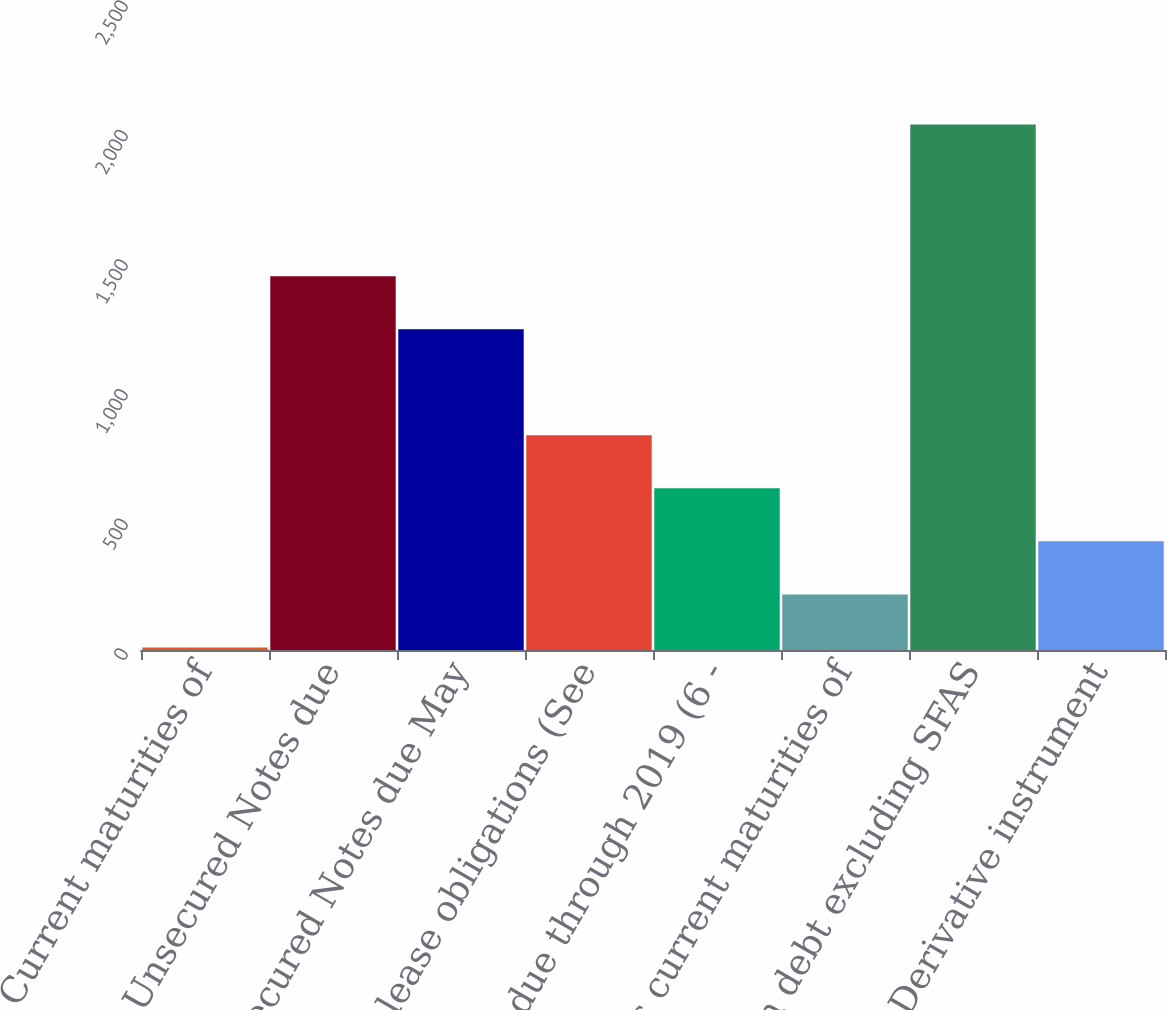<chart> <loc_0><loc_0><loc_500><loc_500><bar_chart><fcel>Current maturities of<fcel>Senior Unsecured Notes due<fcel>Senior Unsecured Notes due May<fcel>Capital lease obligations (See<fcel>Other due through 2019 (6 -<fcel>Less current maturities of<fcel>Long-term debt excluding SFAS<fcel>Derivative instrument<nl><fcel>10<fcel>1442.2<fcel>1237.6<fcel>828.4<fcel>623.8<fcel>214.6<fcel>2027<fcel>419.2<nl></chart> 